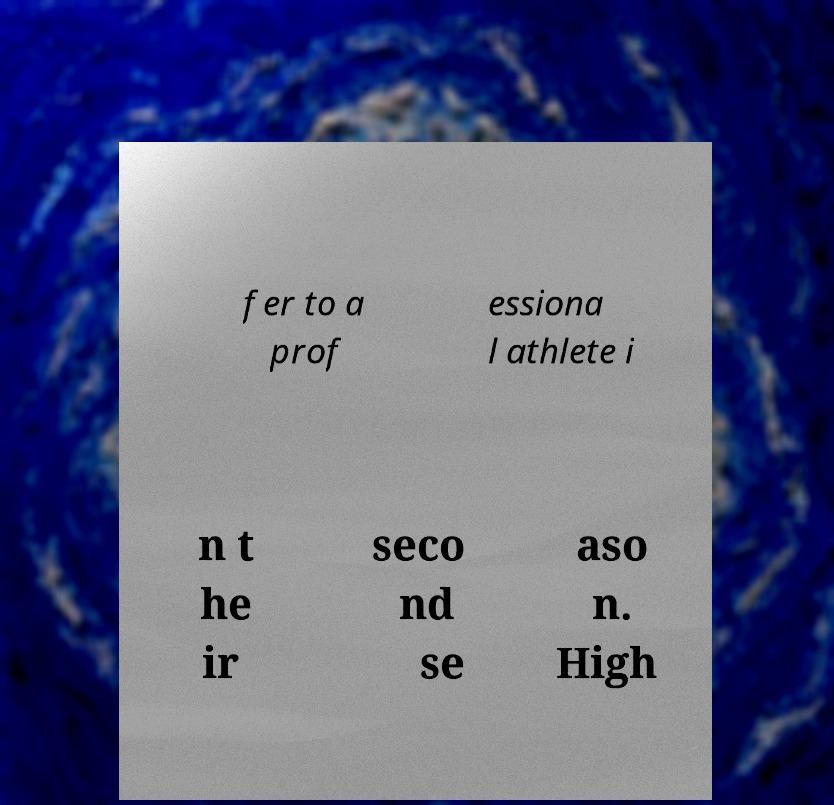There's text embedded in this image that I need extracted. Can you transcribe it verbatim? fer to a prof essiona l athlete i n t he ir seco nd se aso n. High 